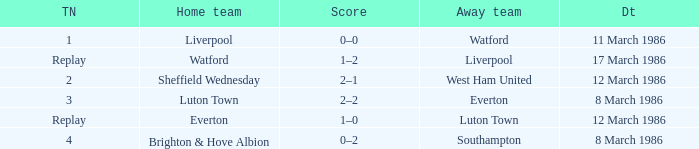Who was the home team in the match against Luton Town? Everton. 